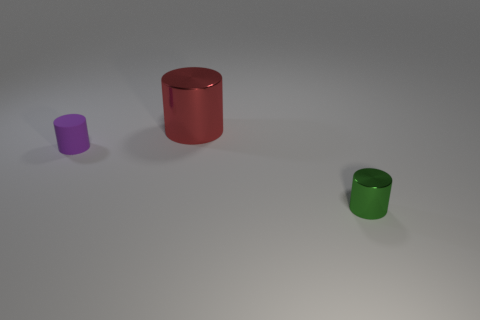Add 1 blue rubber objects. How many objects exist? 4 Subtract 1 green cylinders. How many objects are left? 2 Subtract all purple cylinders. Subtract all green shiny cylinders. How many objects are left? 1 Add 2 metallic cylinders. How many metallic cylinders are left? 4 Add 1 blue cylinders. How many blue cylinders exist? 1 